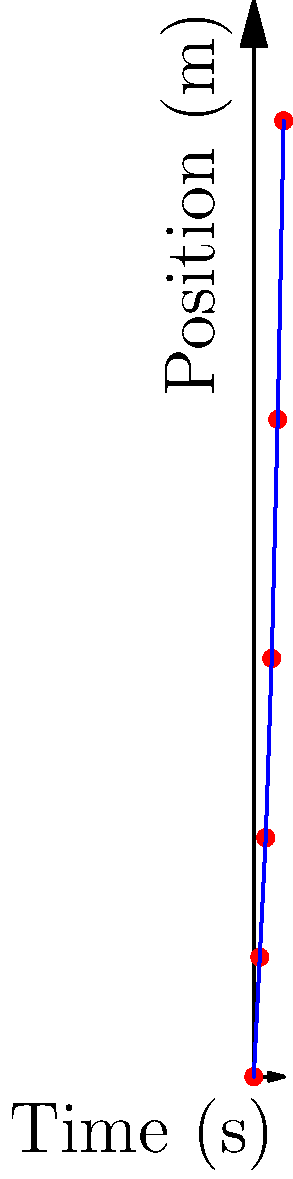Given the time-stamped hand positions of a baseball pitcher during a pitch as shown in the graph, calculate the average velocity between t = 0.2s and t = 0.4s, and the instantaneous acceleration at t = 0.3s. Round your answers to two decimal places. Step 1: Calculate the average velocity between t = 0.2s and t = 0.4s.
Average velocity = (Change in position) / (Change in time)
$$ v_{avg} = \frac{\Delta x}{\Delta t} = \frac{x_2 - x_1}{t_2 - t_1} $$
At t = 0.2s, x = 4m
At t = 0.4s, x = 11m
$$ v_{avg} = \frac{11m - 4m}{0.4s - 0.2s} = \frac{7m}{0.2s} = 35 m/s $$

Step 2: Calculate the instantaneous acceleration at t = 0.3s.
We can approximate this using the average acceleration between t = 0.2s and t = 0.4s.
Acceleration = (Change in velocity) / (Change in time)
$$ a = \frac{\Delta v}{\Delta t} $$

Calculate velocities at t = 0.2s and t = 0.4s:
v(0.2s) = (4m - 2m) / (0.2s - 0.1s) = 20 m/s
v(0.4s) = (11m - 7m) / (0.4s - 0.3s) = 40 m/s

Now calculate acceleration:
$$ a = \frac{40 m/s - 20 m/s}{0.4s - 0.2s} = \frac{20 m/s}{0.2s} = 100 m/s^2 $$

Rounding to two decimal places:
Average velocity = 35.00 m/s
Instantaneous acceleration ≈ 100.00 m/s²
Answer: 35.00 m/s, 100.00 m/s² 